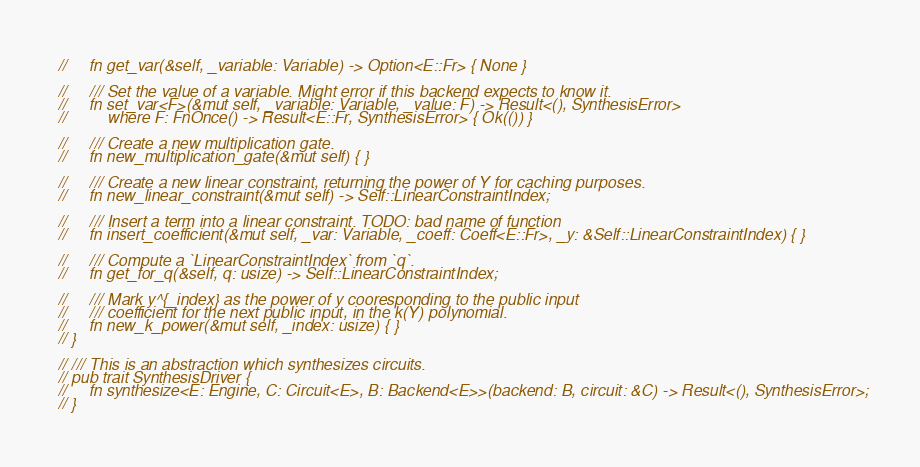<code> <loc_0><loc_0><loc_500><loc_500><_Rust_>//     fn get_var(&self, _variable: Variable) -> Option<E::Fr> { None }

//     /// Set the value of a variable. Might error if this backend expects to know it.
//     fn set_var<F>(&mut self, _variable: Variable, _value: F) -> Result<(), SynthesisError>
//         where F: FnOnce() -> Result<E::Fr, SynthesisError> { Ok(()) }

//     /// Create a new multiplication gate.
//     fn new_multiplication_gate(&mut self) { }

//     /// Create a new linear constraint, returning the power of Y for caching purposes.
//     fn new_linear_constraint(&mut self) -> Self::LinearConstraintIndex;

//     /// Insert a term into a linear constraint. TODO: bad name of function
//     fn insert_coefficient(&mut self, _var: Variable, _coeff: Coeff<E::Fr>, _y: &Self::LinearConstraintIndex) { }

//     /// Compute a `LinearConstraintIndex` from `q`.
//     fn get_for_q(&self, q: usize) -> Self::LinearConstraintIndex;

//     /// Mark y^{_index} as the power of y cooresponding to the public input
//     /// coefficient for the next public input, in the k(Y) polynomial.
//     fn new_k_power(&mut self, _index: usize) { }
// }

// /// This is an abstraction which synthesizes circuits.
// pub trait SynthesisDriver {
//     fn synthesize<E: Engine, C: Circuit<E>, B: Backend<E>>(backend: B, circuit: &C) -> Result<(), SynthesisError>;
// }</code> 